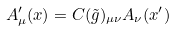<formula> <loc_0><loc_0><loc_500><loc_500>A ^ { \prime } _ { \mu } ( x ) = C ( \tilde { g } ) _ { \mu \nu } A _ { \nu } ( x ^ { \prime } )</formula> 